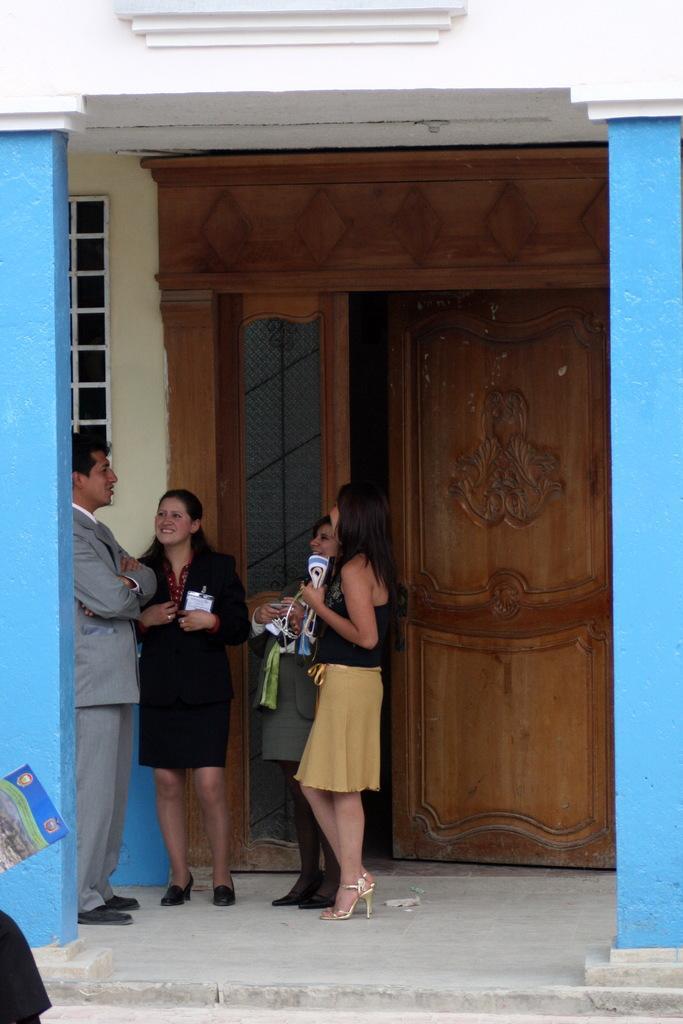Can you describe this image briefly? In this picture, we see four people are standing and all of them are smiling. I think the man in grey blazer is talking. The woman in black T-shirt and yellow skirt is holding something in her hands. Behind them, we see a brown color door, yellow wall and a window. On either side of the picture, we see two pillars in blue color. In the left bottom of the picture, we see the legs of the person and a book. 